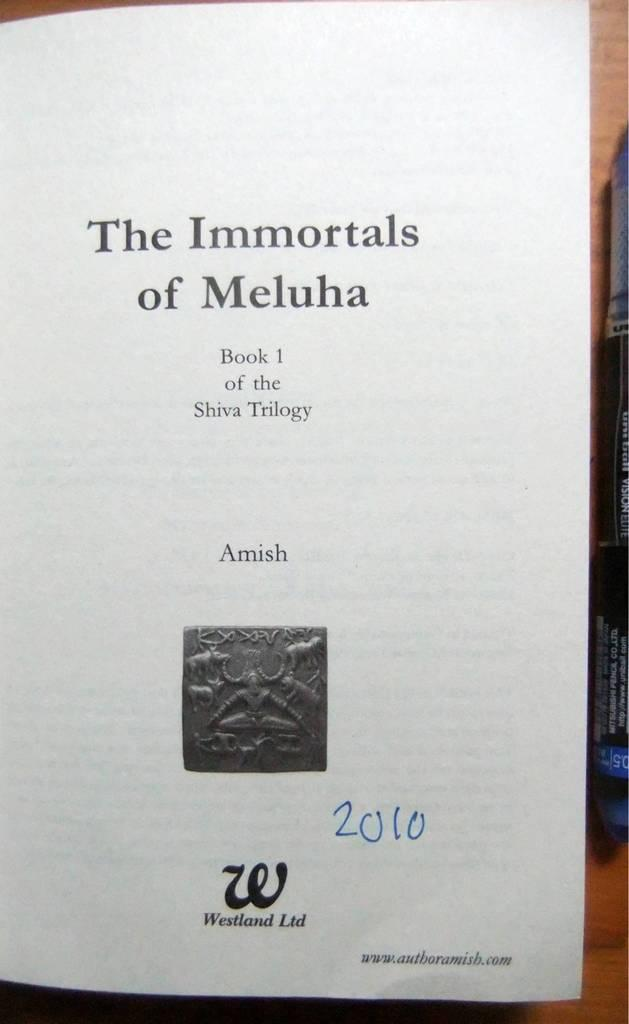<image>
Describe the image concisely. The title page of The Immortals of Meluha has the date 2010 written on it in pen. 